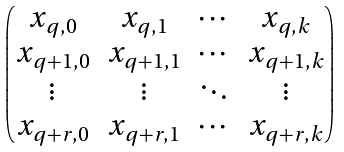Convert formula to latex. <formula><loc_0><loc_0><loc_500><loc_500>\begin{pmatrix} x _ { q , 0 } & x _ { q , 1 } & \cdots & x _ { q , k } \\ x _ { q + 1 , 0 } & x _ { q + 1 , 1 } & \cdots & x _ { q + 1 , k } \\ \vdots & \vdots & \ddots & \vdots \\ x _ { q + r , 0 } & x _ { q + r , 1 } & \cdots & x _ { q + r , k } \end{pmatrix}</formula> 